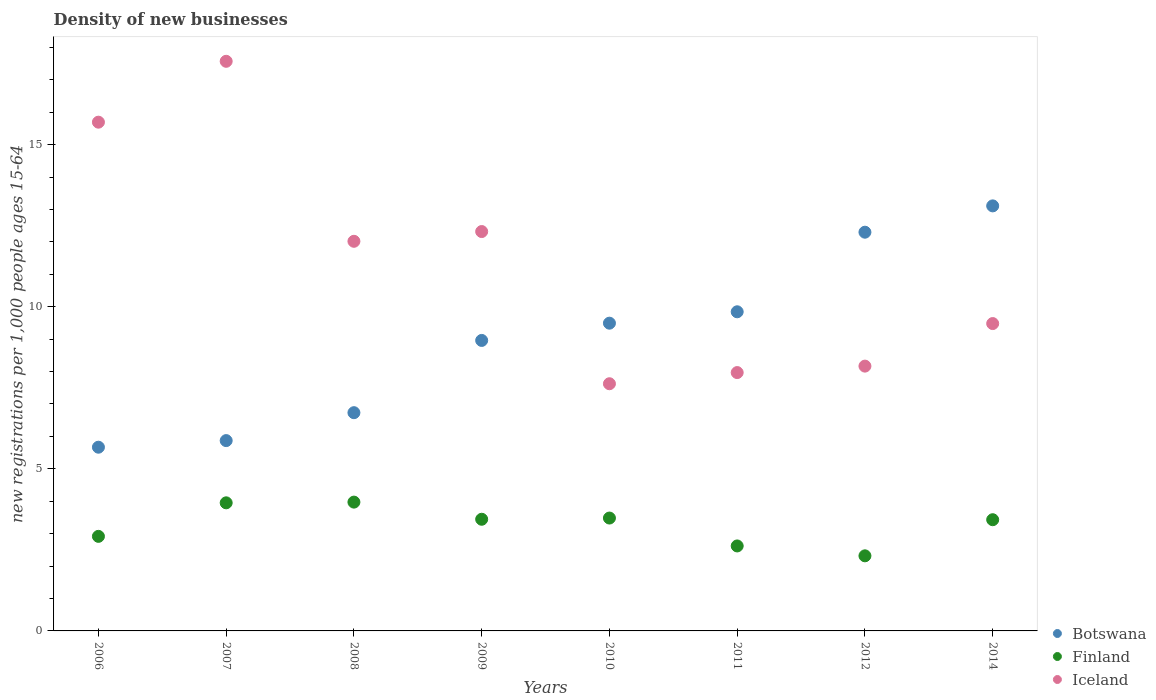How many different coloured dotlines are there?
Offer a terse response. 3. Is the number of dotlines equal to the number of legend labels?
Provide a short and direct response. Yes. What is the number of new registrations in Finland in 2006?
Your answer should be very brief. 2.92. Across all years, what is the maximum number of new registrations in Iceland?
Give a very brief answer. 17.57. Across all years, what is the minimum number of new registrations in Iceland?
Your answer should be compact. 7.62. In which year was the number of new registrations in Iceland minimum?
Your answer should be very brief. 2010. What is the total number of new registrations in Finland in the graph?
Your response must be concise. 26.13. What is the difference between the number of new registrations in Iceland in 2009 and that in 2014?
Your answer should be compact. 2.84. What is the difference between the number of new registrations in Iceland in 2006 and the number of new registrations in Botswana in 2011?
Ensure brevity in your answer.  5.85. What is the average number of new registrations in Botswana per year?
Your response must be concise. 9. In the year 2014, what is the difference between the number of new registrations in Iceland and number of new registrations in Botswana?
Offer a terse response. -3.63. In how many years, is the number of new registrations in Finland greater than 12?
Provide a succinct answer. 0. What is the ratio of the number of new registrations in Finland in 2007 to that in 2012?
Offer a very short reply. 1.71. Is the number of new registrations in Botswana in 2006 less than that in 2012?
Your answer should be very brief. Yes. Is the difference between the number of new registrations in Iceland in 2006 and 2008 greater than the difference between the number of new registrations in Botswana in 2006 and 2008?
Keep it short and to the point. Yes. What is the difference between the highest and the second highest number of new registrations in Botswana?
Give a very brief answer. 0.81. What is the difference between the highest and the lowest number of new registrations in Finland?
Ensure brevity in your answer.  1.66. Is the sum of the number of new registrations in Botswana in 2010 and 2012 greater than the maximum number of new registrations in Finland across all years?
Ensure brevity in your answer.  Yes. Is it the case that in every year, the sum of the number of new registrations in Finland and number of new registrations in Botswana  is greater than the number of new registrations in Iceland?
Offer a very short reply. No. Does the number of new registrations in Iceland monotonically increase over the years?
Keep it short and to the point. No. Is the number of new registrations in Iceland strictly greater than the number of new registrations in Botswana over the years?
Provide a short and direct response. No. Is the number of new registrations in Botswana strictly less than the number of new registrations in Iceland over the years?
Provide a short and direct response. No. How many years are there in the graph?
Offer a terse response. 8. What is the difference between two consecutive major ticks on the Y-axis?
Provide a succinct answer. 5. Does the graph contain any zero values?
Your answer should be very brief. No. How are the legend labels stacked?
Provide a succinct answer. Vertical. What is the title of the graph?
Provide a succinct answer. Density of new businesses. What is the label or title of the Y-axis?
Your answer should be very brief. New registrations per 1,0 people ages 15-64. What is the new registrations per 1,000 people ages 15-64 of Botswana in 2006?
Make the answer very short. 5.67. What is the new registrations per 1,000 people ages 15-64 of Finland in 2006?
Your answer should be compact. 2.92. What is the new registrations per 1,000 people ages 15-64 in Iceland in 2006?
Offer a very short reply. 15.69. What is the new registrations per 1,000 people ages 15-64 of Botswana in 2007?
Give a very brief answer. 5.87. What is the new registrations per 1,000 people ages 15-64 in Finland in 2007?
Provide a short and direct response. 3.95. What is the new registrations per 1,000 people ages 15-64 in Iceland in 2007?
Provide a succinct answer. 17.57. What is the new registrations per 1,000 people ages 15-64 in Botswana in 2008?
Offer a very short reply. 6.73. What is the new registrations per 1,000 people ages 15-64 of Finland in 2008?
Offer a terse response. 3.97. What is the new registrations per 1,000 people ages 15-64 of Iceland in 2008?
Give a very brief answer. 12.02. What is the new registrations per 1,000 people ages 15-64 of Botswana in 2009?
Offer a terse response. 8.96. What is the new registrations per 1,000 people ages 15-64 in Finland in 2009?
Ensure brevity in your answer.  3.44. What is the new registrations per 1,000 people ages 15-64 of Iceland in 2009?
Keep it short and to the point. 12.32. What is the new registrations per 1,000 people ages 15-64 in Botswana in 2010?
Offer a very short reply. 9.49. What is the new registrations per 1,000 people ages 15-64 of Finland in 2010?
Your answer should be compact. 3.48. What is the new registrations per 1,000 people ages 15-64 in Iceland in 2010?
Keep it short and to the point. 7.62. What is the new registrations per 1,000 people ages 15-64 in Botswana in 2011?
Your answer should be compact. 9.84. What is the new registrations per 1,000 people ages 15-64 in Finland in 2011?
Make the answer very short. 2.62. What is the new registrations per 1,000 people ages 15-64 in Iceland in 2011?
Offer a very short reply. 7.97. What is the new registrations per 1,000 people ages 15-64 of Botswana in 2012?
Ensure brevity in your answer.  12.3. What is the new registrations per 1,000 people ages 15-64 in Finland in 2012?
Give a very brief answer. 2.32. What is the new registrations per 1,000 people ages 15-64 in Iceland in 2012?
Offer a terse response. 8.17. What is the new registrations per 1,000 people ages 15-64 in Botswana in 2014?
Your response must be concise. 13.11. What is the new registrations per 1,000 people ages 15-64 of Finland in 2014?
Give a very brief answer. 3.43. What is the new registrations per 1,000 people ages 15-64 in Iceland in 2014?
Your response must be concise. 9.48. Across all years, what is the maximum new registrations per 1,000 people ages 15-64 of Botswana?
Keep it short and to the point. 13.11. Across all years, what is the maximum new registrations per 1,000 people ages 15-64 of Finland?
Your answer should be very brief. 3.97. Across all years, what is the maximum new registrations per 1,000 people ages 15-64 of Iceland?
Your response must be concise. 17.57. Across all years, what is the minimum new registrations per 1,000 people ages 15-64 of Botswana?
Keep it short and to the point. 5.67. Across all years, what is the minimum new registrations per 1,000 people ages 15-64 in Finland?
Give a very brief answer. 2.32. Across all years, what is the minimum new registrations per 1,000 people ages 15-64 in Iceland?
Your response must be concise. 7.62. What is the total new registrations per 1,000 people ages 15-64 of Botswana in the graph?
Offer a terse response. 71.97. What is the total new registrations per 1,000 people ages 15-64 in Finland in the graph?
Make the answer very short. 26.13. What is the total new registrations per 1,000 people ages 15-64 of Iceland in the graph?
Keep it short and to the point. 90.84. What is the difference between the new registrations per 1,000 people ages 15-64 in Botswana in 2006 and that in 2007?
Offer a terse response. -0.2. What is the difference between the new registrations per 1,000 people ages 15-64 in Finland in 2006 and that in 2007?
Offer a very short reply. -1.03. What is the difference between the new registrations per 1,000 people ages 15-64 of Iceland in 2006 and that in 2007?
Keep it short and to the point. -1.88. What is the difference between the new registrations per 1,000 people ages 15-64 in Botswana in 2006 and that in 2008?
Your answer should be very brief. -1.06. What is the difference between the new registrations per 1,000 people ages 15-64 in Finland in 2006 and that in 2008?
Make the answer very short. -1.06. What is the difference between the new registrations per 1,000 people ages 15-64 in Iceland in 2006 and that in 2008?
Make the answer very short. 3.67. What is the difference between the new registrations per 1,000 people ages 15-64 in Botswana in 2006 and that in 2009?
Provide a succinct answer. -3.29. What is the difference between the new registrations per 1,000 people ages 15-64 of Finland in 2006 and that in 2009?
Keep it short and to the point. -0.53. What is the difference between the new registrations per 1,000 people ages 15-64 in Iceland in 2006 and that in 2009?
Your answer should be very brief. 3.37. What is the difference between the new registrations per 1,000 people ages 15-64 in Botswana in 2006 and that in 2010?
Offer a very short reply. -3.83. What is the difference between the new registrations per 1,000 people ages 15-64 in Finland in 2006 and that in 2010?
Provide a succinct answer. -0.56. What is the difference between the new registrations per 1,000 people ages 15-64 in Iceland in 2006 and that in 2010?
Your answer should be compact. 8.07. What is the difference between the new registrations per 1,000 people ages 15-64 of Botswana in 2006 and that in 2011?
Provide a succinct answer. -4.18. What is the difference between the new registrations per 1,000 people ages 15-64 of Finland in 2006 and that in 2011?
Your response must be concise. 0.3. What is the difference between the new registrations per 1,000 people ages 15-64 in Iceland in 2006 and that in 2011?
Ensure brevity in your answer.  7.72. What is the difference between the new registrations per 1,000 people ages 15-64 in Botswana in 2006 and that in 2012?
Offer a very short reply. -6.63. What is the difference between the new registrations per 1,000 people ages 15-64 in Finland in 2006 and that in 2012?
Give a very brief answer. 0.6. What is the difference between the new registrations per 1,000 people ages 15-64 of Iceland in 2006 and that in 2012?
Offer a very short reply. 7.52. What is the difference between the new registrations per 1,000 people ages 15-64 in Botswana in 2006 and that in 2014?
Offer a terse response. -7.44. What is the difference between the new registrations per 1,000 people ages 15-64 in Finland in 2006 and that in 2014?
Your answer should be very brief. -0.51. What is the difference between the new registrations per 1,000 people ages 15-64 in Iceland in 2006 and that in 2014?
Your answer should be very brief. 6.21. What is the difference between the new registrations per 1,000 people ages 15-64 in Botswana in 2007 and that in 2008?
Ensure brevity in your answer.  -0.86. What is the difference between the new registrations per 1,000 people ages 15-64 in Finland in 2007 and that in 2008?
Make the answer very short. -0.02. What is the difference between the new registrations per 1,000 people ages 15-64 of Iceland in 2007 and that in 2008?
Offer a terse response. 5.55. What is the difference between the new registrations per 1,000 people ages 15-64 in Botswana in 2007 and that in 2009?
Offer a very short reply. -3.09. What is the difference between the new registrations per 1,000 people ages 15-64 of Finland in 2007 and that in 2009?
Provide a short and direct response. 0.51. What is the difference between the new registrations per 1,000 people ages 15-64 of Iceland in 2007 and that in 2009?
Offer a terse response. 5.25. What is the difference between the new registrations per 1,000 people ages 15-64 of Botswana in 2007 and that in 2010?
Give a very brief answer. -3.62. What is the difference between the new registrations per 1,000 people ages 15-64 of Finland in 2007 and that in 2010?
Offer a very short reply. 0.47. What is the difference between the new registrations per 1,000 people ages 15-64 in Iceland in 2007 and that in 2010?
Give a very brief answer. 9.95. What is the difference between the new registrations per 1,000 people ages 15-64 in Botswana in 2007 and that in 2011?
Your answer should be very brief. -3.97. What is the difference between the new registrations per 1,000 people ages 15-64 of Finland in 2007 and that in 2011?
Offer a terse response. 1.33. What is the difference between the new registrations per 1,000 people ages 15-64 of Iceland in 2007 and that in 2011?
Your response must be concise. 9.6. What is the difference between the new registrations per 1,000 people ages 15-64 of Botswana in 2007 and that in 2012?
Give a very brief answer. -6.43. What is the difference between the new registrations per 1,000 people ages 15-64 in Finland in 2007 and that in 2012?
Make the answer very short. 1.63. What is the difference between the new registrations per 1,000 people ages 15-64 of Iceland in 2007 and that in 2012?
Your response must be concise. 9.4. What is the difference between the new registrations per 1,000 people ages 15-64 in Botswana in 2007 and that in 2014?
Offer a very short reply. -7.24. What is the difference between the new registrations per 1,000 people ages 15-64 of Finland in 2007 and that in 2014?
Keep it short and to the point. 0.52. What is the difference between the new registrations per 1,000 people ages 15-64 of Iceland in 2007 and that in 2014?
Offer a very short reply. 8.09. What is the difference between the new registrations per 1,000 people ages 15-64 of Botswana in 2008 and that in 2009?
Ensure brevity in your answer.  -2.23. What is the difference between the new registrations per 1,000 people ages 15-64 of Finland in 2008 and that in 2009?
Keep it short and to the point. 0.53. What is the difference between the new registrations per 1,000 people ages 15-64 in Iceland in 2008 and that in 2009?
Make the answer very short. -0.3. What is the difference between the new registrations per 1,000 people ages 15-64 of Botswana in 2008 and that in 2010?
Make the answer very short. -2.76. What is the difference between the new registrations per 1,000 people ages 15-64 of Finland in 2008 and that in 2010?
Give a very brief answer. 0.49. What is the difference between the new registrations per 1,000 people ages 15-64 in Iceland in 2008 and that in 2010?
Offer a very short reply. 4.39. What is the difference between the new registrations per 1,000 people ages 15-64 of Botswana in 2008 and that in 2011?
Provide a succinct answer. -3.11. What is the difference between the new registrations per 1,000 people ages 15-64 of Finland in 2008 and that in 2011?
Provide a short and direct response. 1.35. What is the difference between the new registrations per 1,000 people ages 15-64 of Iceland in 2008 and that in 2011?
Your answer should be compact. 4.05. What is the difference between the new registrations per 1,000 people ages 15-64 of Botswana in 2008 and that in 2012?
Ensure brevity in your answer.  -5.57. What is the difference between the new registrations per 1,000 people ages 15-64 in Finland in 2008 and that in 2012?
Your response must be concise. 1.66. What is the difference between the new registrations per 1,000 people ages 15-64 of Iceland in 2008 and that in 2012?
Provide a short and direct response. 3.85. What is the difference between the new registrations per 1,000 people ages 15-64 in Botswana in 2008 and that in 2014?
Ensure brevity in your answer.  -6.38. What is the difference between the new registrations per 1,000 people ages 15-64 in Finland in 2008 and that in 2014?
Ensure brevity in your answer.  0.54. What is the difference between the new registrations per 1,000 people ages 15-64 of Iceland in 2008 and that in 2014?
Make the answer very short. 2.54. What is the difference between the new registrations per 1,000 people ages 15-64 of Botswana in 2009 and that in 2010?
Your answer should be very brief. -0.53. What is the difference between the new registrations per 1,000 people ages 15-64 of Finland in 2009 and that in 2010?
Ensure brevity in your answer.  -0.04. What is the difference between the new registrations per 1,000 people ages 15-64 of Iceland in 2009 and that in 2010?
Your response must be concise. 4.69. What is the difference between the new registrations per 1,000 people ages 15-64 of Botswana in 2009 and that in 2011?
Provide a succinct answer. -0.88. What is the difference between the new registrations per 1,000 people ages 15-64 of Finland in 2009 and that in 2011?
Ensure brevity in your answer.  0.82. What is the difference between the new registrations per 1,000 people ages 15-64 of Iceland in 2009 and that in 2011?
Your response must be concise. 4.35. What is the difference between the new registrations per 1,000 people ages 15-64 in Botswana in 2009 and that in 2012?
Your answer should be very brief. -3.34. What is the difference between the new registrations per 1,000 people ages 15-64 of Finland in 2009 and that in 2012?
Give a very brief answer. 1.13. What is the difference between the new registrations per 1,000 people ages 15-64 in Iceland in 2009 and that in 2012?
Give a very brief answer. 4.15. What is the difference between the new registrations per 1,000 people ages 15-64 of Botswana in 2009 and that in 2014?
Make the answer very short. -4.15. What is the difference between the new registrations per 1,000 people ages 15-64 of Finland in 2009 and that in 2014?
Offer a very short reply. 0.01. What is the difference between the new registrations per 1,000 people ages 15-64 in Iceland in 2009 and that in 2014?
Provide a short and direct response. 2.84. What is the difference between the new registrations per 1,000 people ages 15-64 of Botswana in 2010 and that in 2011?
Offer a terse response. -0.35. What is the difference between the new registrations per 1,000 people ages 15-64 of Finland in 2010 and that in 2011?
Provide a succinct answer. 0.86. What is the difference between the new registrations per 1,000 people ages 15-64 of Iceland in 2010 and that in 2011?
Ensure brevity in your answer.  -0.34. What is the difference between the new registrations per 1,000 people ages 15-64 of Botswana in 2010 and that in 2012?
Give a very brief answer. -2.81. What is the difference between the new registrations per 1,000 people ages 15-64 in Finland in 2010 and that in 2012?
Make the answer very short. 1.17. What is the difference between the new registrations per 1,000 people ages 15-64 of Iceland in 2010 and that in 2012?
Your answer should be compact. -0.54. What is the difference between the new registrations per 1,000 people ages 15-64 of Botswana in 2010 and that in 2014?
Ensure brevity in your answer.  -3.62. What is the difference between the new registrations per 1,000 people ages 15-64 in Finland in 2010 and that in 2014?
Make the answer very short. 0.05. What is the difference between the new registrations per 1,000 people ages 15-64 of Iceland in 2010 and that in 2014?
Provide a short and direct response. -1.86. What is the difference between the new registrations per 1,000 people ages 15-64 of Botswana in 2011 and that in 2012?
Provide a succinct answer. -2.45. What is the difference between the new registrations per 1,000 people ages 15-64 of Finland in 2011 and that in 2012?
Give a very brief answer. 0.3. What is the difference between the new registrations per 1,000 people ages 15-64 in Iceland in 2011 and that in 2012?
Give a very brief answer. -0.2. What is the difference between the new registrations per 1,000 people ages 15-64 in Botswana in 2011 and that in 2014?
Provide a succinct answer. -3.27. What is the difference between the new registrations per 1,000 people ages 15-64 in Finland in 2011 and that in 2014?
Keep it short and to the point. -0.81. What is the difference between the new registrations per 1,000 people ages 15-64 in Iceland in 2011 and that in 2014?
Ensure brevity in your answer.  -1.51. What is the difference between the new registrations per 1,000 people ages 15-64 in Botswana in 2012 and that in 2014?
Your answer should be compact. -0.81. What is the difference between the new registrations per 1,000 people ages 15-64 of Finland in 2012 and that in 2014?
Ensure brevity in your answer.  -1.11. What is the difference between the new registrations per 1,000 people ages 15-64 in Iceland in 2012 and that in 2014?
Provide a short and direct response. -1.31. What is the difference between the new registrations per 1,000 people ages 15-64 in Botswana in 2006 and the new registrations per 1,000 people ages 15-64 in Finland in 2007?
Your response must be concise. 1.72. What is the difference between the new registrations per 1,000 people ages 15-64 of Botswana in 2006 and the new registrations per 1,000 people ages 15-64 of Iceland in 2007?
Your answer should be very brief. -11.9. What is the difference between the new registrations per 1,000 people ages 15-64 of Finland in 2006 and the new registrations per 1,000 people ages 15-64 of Iceland in 2007?
Keep it short and to the point. -14.65. What is the difference between the new registrations per 1,000 people ages 15-64 in Botswana in 2006 and the new registrations per 1,000 people ages 15-64 in Finland in 2008?
Make the answer very short. 1.69. What is the difference between the new registrations per 1,000 people ages 15-64 in Botswana in 2006 and the new registrations per 1,000 people ages 15-64 in Iceland in 2008?
Offer a terse response. -6.35. What is the difference between the new registrations per 1,000 people ages 15-64 in Finland in 2006 and the new registrations per 1,000 people ages 15-64 in Iceland in 2008?
Give a very brief answer. -9.1. What is the difference between the new registrations per 1,000 people ages 15-64 of Botswana in 2006 and the new registrations per 1,000 people ages 15-64 of Finland in 2009?
Your answer should be very brief. 2.22. What is the difference between the new registrations per 1,000 people ages 15-64 of Botswana in 2006 and the new registrations per 1,000 people ages 15-64 of Iceland in 2009?
Offer a very short reply. -6.65. What is the difference between the new registrations per 1,000 people ages 15-64 in Finland in 2006 and the new registrations per 1,000 people ages 15-64 in Iceland in 2009?
Ensure brevity in your answer.  -9.4. What is the difference between the new registrations per 1,000 people ages 15-64 of Botswana in 2006 and the new registrations per 1,000 people ages 15-64 of Finland in 2010?
Your answer should be very brief. 2.19. What is the difference between the new registrations per 1,000 people ages 15-64 of Botswana in 2006 and the new registrations per 1,000 people ages 15-64 of Iceland in 2010?
Make the answer very short. -1.96. What is the difference between the new registrations per 1,000 people ages 15-64 in Finland in 2006 and the new registrations per 1,000 people ages 15-64 in Iceland in 2010?
Your answer should be very brief. -4.71. What is the difference between the new registrations per 1,000 people ages 15-64 in Botswana in 2006 and the new registrations per 1,000 people ages 15-64 in Finland in 2011?
Ensure brevity in your answer.  3.05. What is the difference between the new registrations per 1,000 people ages 15-64 in Botswana in 2006 and the new registrations per 1,000 people ages 15-64 in Iceland in 2011?
Your answer should be very brief. -2.3. What is the difference between the new registrations per 1,000 people ages 15-64 in Finland in 2006 and the new registrations per 1,000 people ages 15-64 in Iceland in 2011?
Keep it short and to the point. -5.05. What is the difference between the new registrations per 1,000 people ages 15-64 in Botswana in 2006 and the new registrations per 1,000 people ages 15-64 in Finland in 2012?
Ensure brevity in your answer.  3.35. What is the difference between the new registrations per 1,000 people ages 15-64 of Botswana in 2006 and the new registrations per 1,000 people ages 15-64 of Iceland in 2012?
Offer a very short reply. -2.5. What is the difference between the new registrations per 1,000 people ages 15-64 of Finland in 2006 and the new registrations per 1,000 people ages 15-64 of Iceland in 2012?
Your answer should be very brief. -5.25. What is the difference between the new registrations per 1,000 people ages 15-64 of Botswana in 2006 and the new registrations per 1,000 people ages 15-64 of Finland in 2014?
Provide a succinct answer. 2.24. What is the difference between the new registrations per 1,000 people ages 15-64 of Botswana in 2006 and the new registrations per 1,000 people ages 15-64 of Iceland in 2014?
Your response must be concise. -3.81. What is the difference between the new registrations per 1,000 people ages 15-64 in Finland in 2006 and the new registrations per 1,000 people ages 15-64 in Iceland in 2014?
Provide a succinct answer. -6.56. What is the difference between the new registrations per 1,000 people ages 15-64 of Botswana in 2007 and the new registrations per 1,000 people ages 15-64 of Finland in 2008?
Your response must be concise. 1.9. What is the difference between the new registrations per 1,000 people ages 15-64 in Botswana in 2007 and the new registrations per 1,000 people ages 15-64 in Iceland in 2008?
Provide a short and direct response. -6.15. What is the difference between the new registrations per 1,000 people ages 15-64 in Finland in 2007 and the new registrations per 1,000 people ages 15-64 in Iceland in 2008?
Keep it short and to the point. -8.07. What is the difference between the new registrations per 1,000 people ages 15-64 of Botswana in 2007 and the new registrations per 1,000 people ages 15-64 of Finland in 2009?
Your response must be concise. 2.43. What is the difference between the new registrations per 1,000 people ages 15-64 of Botswana in 2007 and the new registrations per 1,000 people ages 15-64 of Iceland in 2009?
Give a very brief answer. -6.45. What is the difference between the new registrations per 1,000 people ages 15-64 of Finland in 2007 and the new registrations per 1,000 people ages 15-64 of Iceland in 2009?
Offer a very short reply. -8.37. What is the difference between the new registrations per 1,000 people ages 15-64 of Botswana in 2007 and the new registrations per 1,000 people ages 15-64 of Finland in 2010?
Your response must be concise. 2.39. What is the difference between the new registrations per 1,000 people ages 15-64 in Botswana in 2007 and the new registrations per 1,000 people ages 15-64 in Iceland in 2010?
Your answer should be compact. -1.75. What is the difference between the new registrations per 1,000 people ages 15-64 of Finland in 2007 and the new registrations per 1,000 people ages 15-64 of Iceland in 2010?
Offer a terse response. -3.67. What is the difference between the new registrations per 1,000 people ages 15-64 of Botswana in 2007 and the new registrations per 1,000 people ages 15-64 of Finland in 2011?
Your answer should be compact. 3.25. What is the difference between the new registrations per 1,000 people ages 15-64 in Botswana in 2007 and the new registrations per 1,000 people ages 15-64 in Iceland in 2011?
Give a very brief answer. -2.1. What is the difference between the new registrations per 1,000 people ages 15-64 of Finland in 2007 and the new registrations per 1,000 people ages 15-64 of Iceland in 2011?
Provide a short and direct response. -4.02. What is the difference between the new registrations per 1,000 people ages 15-64 in Botswana in 2007 and the new registrations per 1,000 people ages 15-64 in Finland in 2012?
Ensure brevity in your answer.  3.55. What is the difference between the new registrations per 1,000 people ages 15-64 of Botswana in 2007 and the new registrations per 1,000 people ages 15-64 of Iceland in 2012?
Your response must be concise. -2.3. What is the difference between the new registrations per 1,000 people ages 15-64 of Finland in 2007 and the new registrations per 1,000 people ages 15-64 of Iceland in 2012?
Offer a terse response. -4.22. What is the difference between the new registrations per 1,000 people ages 15-64 in Botswana in 2007 and the new registrations per 1,000 people ages 15-64 in Finland in 2014?
Keep it short and to the point. 2.44. What is the difference between the new registrations per 1,000 people ages 15-64 of Botswana in 2007 and the new registrations per 1,000 people ages 15-64 of Iceland in 2014?
Ensure brevity in your answer.  -3.61. What is the difference between the new registrations per 1,000 people ages 15-64 of Finland in 2007 and the new registrations per 1,000 people ages 15-64 of Iceland in 2014?
Offer a very short reply. -5.53. What is the difference between the new registrations per 1,000 people ages 15-64 of Botswana in 2008 and the new registrations per 1,000 people ages 15-64 of Finland in 2009?
Your response must be concise. 3.29. What is the difference between the new registrations per 1,000 people ages 15-64 of Botswana in 2008 and the new registrations per 1,000 people ages 15-64 of Iceland in 2009?
Keep it short and to the point. -5.59. What is the difference between the new registrations per 1,000 people ages 15-64 in Finland in 2008 and the new registrations per 1,000 people ages 15-64 in Iceland in 2009?
Your answer should be very brief. -8.35. What is the difference between the new registrations per 1,000 people ages 15-64 of Botswana in 2008 and the new registrations per 1,000 people ages 15-64 of Finland in 2010?
Ensure brevity in your answer.  3.25. What is the difference between the new registrations per 1,000 people ages 15-64 in Botswana in 2008 and the new registrations per 1,000 people ages 15-64 in Iceland in 2010?
Give a very brief answer. -0.89. What is the difference between the new registrations per 1,000 people ages 15-64 of Finland in 2008 and the new registrations per 1,000 people ages 15-64 of Iceland in 2010?
Offer a very short reply. -3.65. What is the difference between the new registrations per 1,000 people ages 15-64 in Botswana in 2008 and the new registrations per 1,000 people ages 15-64 in Finland in 2011?
Your response must be concise. 4.11. What is the difference between the new registrations per 1,000 people ages 15-64 of Botswana in 2008 and the new registrations per 1,000 people ages 15-64 of Iceland in 2011?
Ensure brevity in your answer.  -1.24. What is the difference between the new registrations per 1,000 people ages 15-64 of Finland in 2008 and the new registrations per 1,000 people ages 15-64 of Iceland in 2011?
Offer a terse response. -4. What is the difference between the new registrations per 1,000 people ages 15-64 in Botswana in 2008 and the new registrations per 1,000 people ages 15-64 in Finland in 2012?
Your answer should be compact. 4.42. What is the difference between the new registrations per 1,000 people ages 15-64 in Botswana in 2008 and the new registrations per 1,000 people ages 15-64 in Iceland in 2012?
Your answer should be compact. -1.44. What is the difference between the new registrations per 1,000 people ages 15-64 in Finland in 2008 and the new registrations per 1,000 people ages 15-64 in Iceland in 2012?
Offer a terse response. -4.19. What is the difference between the new registrations per 1,000 people ages 15-64 of Botswana in 2008 and the new registrations per 1,000 people ages 15-64 of Finland in 2014?
Offer a very short reply. 3.3. What is the difference between the new registrations per 1,000 people ages 15-64 of Botswana in 2008 and the new registrations per 1,000 people ages 15-64 of Iceland in 2014?
Give a very brief answer. -2.75. What is the difference between the new registrations per 1,000 people ages 15-64 in Finland in 2008 and the new registrations per 1,000 people ages 15-64 in Iceland in 2014?
Ensure brevity in your answer.  -5.51. What is the difference between the new registrations per 1,000 people ages 15-64 in Botswana in 2009 and the new registrations per 1,000 people ages 15-64 in Finland in 2010?
Ensure brevity in your answer.  5.48. What is the difference between the new registrations per 1,000 people ages 15-64 in Botswana in 2009 and the new registrations per 1,000 people ages 15-64 in Iceland in 2010?
Give a very brief answer. 1.34. What is the difference between the new registrations per 1,000 people ages 15-64 in Finland in 2009 and the new registrations per 1,000 people ages 15-64 in Iceland in 2010?
Give a very brief answer. -4.18. What is the difference between the new registrations per 1,000 people ages 15-64 in Botswana in 2009 and the new registrations per 1,000 people ages 15-64 in Finland in 2011?
Make the answer very short. 6.34. What is the difference between the new registrations per 1,000 people ages 15-64 in Finland in 2009 and the new registrations per 1,000 people ages 15-64 in Iceland in 2011?
Provide a short and direct response. -4.52. What is the difference between the new registrations per 1,000 people ages 15-64 of Botswana in 2009 and the new registrations per 1,000 people ages 15-64 of Finland in 2012?
Give a very brief answer. 6.64. What is the difference between the new registrations per 1,000 people ages 15-64 in Botswana in 2009 and the new registrations per 1,000 people ages 15-64 in Iceland in 2012?
Your response must be concise. 0.79. What is the difference between the new registrations per 1,000 people ages 15-64 in Finland in 2009 and the new registrations per 1,000 people ages 15-64 in Iceland in 2012?
Give a very brief answer. -4.72. What is the difference between the new registrations per 1,000 people ages 15-64 of Botswana in 2009 and the new registrations per 1,000 people ages 15-64 of Finland in 2014?
Your answer should be very brief. 5.53. What is the difference between the new registrations per 1,000 people ages 15-64 in Botswana in 2009 and the new registrations per 1,000 people ages 15-64 in Iceland in 2014?
Your response must be concise. -0.52. What is the difference between the new registrations per 1,000 people ages 15-64 in Finland in 2009 and the new registrations per 1,000 people ages 15-64 in Iceland in 2014?
Your answer should be very brief. -6.04. What is the difference between the new registrations per 1,000 people ages 15-64 of Botswana in 2010 and the new registrations per 1,000 people ages 15-64 of Finland in 2011?
Make the answer very short. 6.87. What is the difference between the new registrations per 1,000 people ages 15-64 of Botswana in 2010 and the new registrations per 1,000 people ages 15-64 of Iceland in 2011?
Offer a terse response. 1.52. What is the difference between the new registrations per 1,000 people ages 15-64 of Finland in 2010 and the new registrations per 1,000 people ages 15-64 of Iceland in 2011?
Give a very brief answer. -4.49. What is the difference between the new registrations per 1,000 people ages 15-64 in Botswana in 2010 and the new registrations per 1,000 people ages 15-64 in Finland in 2012?
Offer a very short reply. 7.18. What is the difference between the new registrations per 1,000 people ages 15-64 in Botswana in 2010 and the new registrations per 1,000 people ages 15-64 in Iceland in 2012?
Provide a succinct answer. 1.32. What is the difference between the new registrations per 1,000 people ages 15-64 in Finland in 2010 and the new registrations per 1,000 people ages 15-64 in Iceland in 2012?
Provide a succinct answer. -4.69. What is the difference between the new registrations per 1,000 people ages 15-64 in Botswana in 2010 and the new registrations per 1,000 people ages 15-64 in Finland in 2014?
Ensure brevity in your answer.  6.06. What is the difference between the new registrations per 1,000 people ages 15-64 of Botswana in 2010 and the new registrations per 1,000 people ages 15-64 of Iceland in 2014?
Offer a terse response. 0.01. What is the difference between the new registrations per 1,000 people ages 15-64 of Finland in 2010 and the new registrations per 1,000 people ages 15-64 of Iceland in 2014?
Give a very brief answer. -6. What is the difference between the new registrations per 1,000 people ages 15-64 of Botswana in 2011 and the new registrations per 1,000 people ages 15-64 of Finland in 2012?
Keep it short and to the point. 7.53. What is the difference between the new registrations per 1,000 people ages 15-64 of Botswana in 2011 and the new registrations per 1,000 people ages 15-64 of Iceland in 2012?
Your answer should be compact. 1.68. What is the difference between the new registrations per 1,000 people ages 15-64 of Finland in 2011 and the new registrations per 1,000 people ages 15-64 of Iceland in 2012?
Your response must be concise. -5.55. What is the difference between the new registrations per 1,000 people ages 15-64 in Botswana in 2011 and the new registrations per 1,000 people ages 15-64 in Finland in 2014?
Your answer should be compact. 6.41. What is the difference between the new registrations per 1,000 people ages 15-64 of Botswana in 2011 and the new registrations per 1,000 people ages 15-64 of Iceland in 2014?
Keep it short and to the point. 0.36. What is the difference between the new registrations per 1,000 people ages 15-64 of Finland in 2011 and the new registrations per 1,000 people ages 15-64 of Iceland in 2014?
Ensure brevity in your answer.  -6.86. What is the difference between the new registrations per 1,000 people ages 15-64 of Botswana in 2012 and the new registrations per 1,000 people ages 15-64 of Finland in 2014?
Give a very brief answer. 8.87. What is the difference between the new registrations per 1,000 people ages 15-64 of Botswana in 2012 and the new registrations per 1,000 people ages 15-64 of Iceland in 2014?
Your answer should be very brief. 2.82. What is the difference between the new registrations per 1,000 people ages 15-64 of Finland in 2012 and the new registrations per 1,000 people ages 15-64 of Iceland in 2014?
Your answer should be very brief. -7.16. What is the average new registrations per 1,000 people ages 15-64 in Botswana per year?
Give a very brief answer. 9. What is the average new registrations per 1,000 people ages 15-64 in Finland per year?
Make the answer very short. 3.27. What is the average new registrations per 1,000 people ages 15-64 of Iceland per year?
Offer a very short reply. 11.35. In the year 2006, what is the difference between the new registrations per 1,000 people ages 15-64 of Botswana and new registrations per 1,000 people ages 15-64 of Finland?
Provide a short and direct response. 2.75. In the year 2006, what is the difference between the new registrations per 1,000 people ages 15-64 of Botswana and new registrations per 1,000 people ages 15-64 of Iceland?
Offer a very short reply. -10.03. In the year 2006, what is the difference between the new registrations per 1,000 people ages 15-64 in Finland and new registrations per 1,000 people ages 15-64 in Iceland?
Provide a short and direct response. -12.78. In the year 2007, what is the difference between the new registrations per 1,000 people ages 15-64 in Botswana and new registrations per 1,000 people ages 15-64 in Finland?
Provide a succinct answer. 1.92. In the year 2007, what is the difference between the new registrations per 1,000 people ages 15-64 in Botswana and new registrations per 1,000 people ages 15-64 in Iceland?
Provide a succinct answer. -11.7. In the year 2007, what is the difference between the new registrations per 1,000 people ages 15-64 of Finland and new registrations per 1,000 people ages 15-64 of Iceland?
Give a very brief answer. -13.62. In the year 2008, what is the difference between the new registrations per 1,000 people ages 15-64 of Botswana and new registrations per 1,000 people ages 15-64 of Finland?
Your answer should be compact. 2.76. In the year 2008, what is the difference between the new registrations per 1,000 people ages 15-64 in Botswana and new registrations per 1,000 people ages 15-64 in Iceland?
Your answer should be very brief. -5.29. In the year 2008, what is the difference between the new registrations per 1,000 people ages 15-64 of Finland and new registrations per 1,000 people ages 15-64 of Iceland?
Ensure brevity in your answer.  -8.04. In the year 2009, what is the difference between the new registrations per 1,000 people ages 15-64 in Botswana and new registrations per 1,000 people ages 15-64 in Finland?
Offer a terse response. 5.52. In the year 2009, what is the difference between the new registrations per 1,000 people ages 15-64 of Botswana and new registrations per 1,000 people ages 15-64 of Iceland?
Provide a short and direct response. -3.36. In the year 2009, what is the difference between the new registrations per 1,000 people ages 15-64 of Finland and new registrations per 1,000 people ages 15-64 of Iceland?
Provide a short and direct response. -8.87. In the year 2010, what is the difference between the new registrations per 1,000 people ages 15-64 of Botswana and new registrations per 1,000 people ages 15-64 of Finland?
Make the answer very short. 6.01. In the year 2010, what is the difference between the new registrations per 1,000 people ages 15-64 of Botswana and new registrations per 1,000 people ages 15-64 of Iceland?
Ensure brevity in your answer.  1.87. In the year 2010, what is the difference between the new registrations per 1,000 people ages 15-64 of Finland and new registrations per 1,000 people ages 15-64 of Iceland?
Your answer should be compact. -4.14. In the year 2011, what is the difference between the new registrations per 1,000 people ages 15-64 of Botswana and new registrations per 1,000 people ages 15-64 of Finland?
Ensure brevity in your answer.  7.22. In the year 2011, what is the difference between the new registrations per 1,000 people ages 15-64 in Botswana and new registrations per 1,000 people ages 15-64 in Iceland?
Provide a short and direct response. 1.87. In the year 2011, what is the difference between the new registrations per 1,000 people ages 15-64 in Finland and new registrations per 1,000 people ages 15-64 in Iceland?
Your answer should be very brief. -5.35. In the year 2012, what is the difference between the new registrations per 1,000 people ages 15-64 in Botswana and new registrations per 1,000 people ages 15-64 in Finland?
Keep it short and to the point. 9.98. In the year 2012, what is the difference between the new registrations per 1,000 people ages 15-64 in Botswana and new registrations per 1,000 people ages 15-64 in Iceland?
Make the answer very short. 4.13. In the year 2012, what is the difference between the new registrations per 1,000 people ages 15-64 of Finland and new registrations per 1,000 people ages 15-64 of Iceland?
Your answer should be compact. -5.85. In the year 2014, what is the difference between the new registrations per 1,000 people ages 15-64 of Botswana and new registrations per 1,000 people ages 15-64 of Finland?
Offer a very short reply. 9.68. In the year 2014, what is the difference between the new registrations per 1,000 people ages 15-64 in Botswana and new registrations per 1,000 people ages 15-64 in Iceland?
Keep it short and to the point. 3.63. In the year 2014, what is the difference between the new registrations per 1,000 people ages 15-64 in Finland and new registrations per 1,000 people ages 15-64 in Iceland?
Offer a very short reply. -6.05. What is the ratio of the new registrations per 1,000 people ages 15-64 in Botswana in 2006 to that in 2007?
Offer a very short reply. 0.97. What is the ratio of the new registrations per 1,000 people ages 15-64 in Finland in 2006 to that in 2007?
Keep it short and to the point. 0.74. What is the ratio of the new registrations per 1,000 people ages 15-64 in Iceland in 2006 to that in 2007?
Ensure brevity in your answer.  0.89. What is the ratio of the new registrations per 1,000 people ages 15-64 in Botswana in 2006 to that in 2008?
Make the answer very short. 0.84. What is the ratio of the new registrations per 1,000 people ages 15-64 of Finland in 2006 to that in 2008?
Give a very brief answer. 0.73. What is the ratio of the new registrations per 1,000 people ages 15-64 of Iceland in 2006 to that in 2008?
Provide a short and direct response. 1.31. What is the ratio of the new registrations per 1,000 people ages 15-64 of Botswana in 2006 to that in 2009?
Your answer should be very brief. 0.63. What is the ratio of the new registrations per 1,000 people ages 15-64 in Finland in 2006 to that in 2009?
Make the answer very short. 0.85. What is the ratio of the new registrations per 1,000 people ages 15-64 of Iceland in 2006 to that in 2009?
Offer a terse response. 1.27. What is the ratio of the new registrations per 1,000 people ages 15-64 in Botswana in 2006 to that in 2010?
Ensure brevity in your answer.  0.6. What is the ratio of the new registrations per 1,000 people ages 15-64 of Finland in 2006 to that in 2010?
Offer a terse response. 0.84. What is the ratio of the new registrations per 1,000 people ages 15-64 in Iceland in 2006 to that in 2010?
Offer a terse response. 2.06. What is the ratio of the new registrations per 1,000 people ages 15-64 in Botswana in 2006 to that in 2011?
Provide a short and direct response. 0.58. What is the ratio of the new registrations per 1,000 people ages 15-64 in Finland in 2006 to that in 2011?
Your response must be concise. 1.11. What is the ratio of the new registrations per 1,000 people ages 15-64 of Iceland in 2006 to that in 2011?
Give a very brief answer. 1.97. What is the ratio of the new registrations per 1,000 people ages 15-64 of Botswana in 2006 to that in 2012?
Give a very brief answer. 0.46. What is the ratio of the new registrations per 1,000 people ages 15-64 in Finland in 2006 to that in 2012?
Provide a short and direct response. 1.26. What is the ratio of the new registrations per 1,000 people ages 15-64 of Iceland in 2006 to that in 2012?
Keep it short and to the point. 1.92. What is the ratio of the new registrations per 1,000 people ages 15-64 of Botswana in 2006 to that in 2014?
Provide a short and direct response. 0.43. What is the ratio of the new registrations per 1,000 people ages 15-64 in Finland in 2006 to that in 2014?
Give a very brief answer. 0.85. What is the ratio of the new registrations per 1,000 people ages 15-64 in Iceland in 2006 to that in 2014?
Offer a terse response. 1.66. What is the ratio of the new registrations per 1,000 people ages 15-64 of Botswana in 2007 to that in 2008?
Provide a succinct answer. 0.87. What is the ratio of the new registrations per 1,000 people ages 15-64 of Iceland in 2007 to that in 2008?
Your answer should be compact. 1.46. What is the ratio of the new registrations per 1,000 people ages 15-64 of Botswana in 2007 to that in 2009?
Make the answer very short. 0.66. What is the ratio of the new registrations per 1,000 people ages 15-64 in Finland in 2007 to that in 2009?
Keep it short and to the point. 1.15. What is the ratio of the new registrations per 1,000 people ages 15-64 in Iceland in 2007 to that in 2009?
Provide a succinct answer. 1.43. What is the ratio of the new registrations per 1,000 people ages 15-64 in Botswana in 2007 to that in 2010?
Your answer should be very brief. 0.62. What is the ratio of the new registrations per 1,000 people ages 15-64 of Finland in 2007 to that in 2010?
Provide a short and direct response. 1.13. What is the ratio of the new registrations per 1,000 people ages 15-64 of Iceland in 2007 to that in 2010?
Your answer should be compact. 2.3. What is the ratio of the new registrations per 1,000 people ages 15-64 in Botswana in 2007 to that in 2011?
Your answer should be very brief. 0.6. What is the ratio of the new registrations per 1,000 people ages 15-64 of Finland in 2007 to that in 2011?
Keep it short and to the point. 1.51. What is the ratio of the new registrations per 1,000 people ages 15-64 of Iceland in 2007 to that in 2011?
Give a very brief answer. 2.2. What is the ratio of the new registrations per 1,000 people ages 15-64 of Botswana in 2007 to that in 2012?
Give a very brief answer. 0.48. What is the ratio of the new registrations per 1,000 people ages 15-64 of Finland in 2007 to that in 2012?
Make the answer very short. 1.71. What is the ratio of the new registrations per 1,000 people ages 15-64 in Iceland in 2007 to that in 2012?
Your answer should be very brief. 2.15. What is the ratio of the new registrations per 1,000 people ages 15-64 of Botswana in 2007 to that in 2014?
Provide a short and direct response. 0.45. What is the ratio of the new registrations per 1,000 people ages 15-64 in Finland in 2007 to that in 2014?
Provide a succinct answer. 1.15. What is the ratio of the new registrations per 1,000 people ages 15-64 of Iceland in 2007 to that in 2014?
Make the answer very short. 1.85. What is the ratio of the new registrations per 1,000 people ages 15-64 of Botswana in 2008 to that in 2009?
Provide a succinct answer. 0.75. What is the ratio of the new registrations per 1,000 people ages 15-64 in Finland in 2008 to that in 2009?
Offer a terse response. 1.15. What is the ratio of the new registrations per 1,000 people ages 15-64 of Iceland in 2008 to that in 2009?
Offer a very short reply. 0.98. What is the ratio of the new registrations per 1,000 people ages 15-64 of Botswana in 2008 to that in 2010?
Provide a short and direct response. 0.71. What is the ratio of the new registrations per 1,000 people ages 15-64 of Finland in 2008 to that in 2010?
Offer a terse response. 1.14. What is the ratio of the new registrations per 1,000 people ages 15-64 of Iceland in 2008 to that in 2010?
Give a very brief answer. 1.58. What is the ratio of the new registrations per 1,000 people ages 15-64 of Botswana in 2008 to that in 2011?
Provide a short and direct response. 0.68. What is the ratio of the new registrations per 1,000 people ages 15-64 in Finland in 2008 to that in 2011?
Provide a succinct answer. 1.52. What is the ratio of the new registrations per 1,000 people ages 15-64 in Iceland in 2008 to that in 2011?
Your response must be concise. 1.51. What is the ratio of the new registrations per 1,000 people ages 15-64 in Botswana in 2008 to that in 2012?
Ensure brevity in your answer.  0.55. What is the ratio of the new registrations per 1,000 people ages 15-64 in Finland in 2008 to that in 2012?
Your answer should be compact. 1.72. What is the ratio of the new registrations per 1,000 people ages 15-64 in Iceland in 2008 to that in 2012?
Keep it short and to the point. 1.47. What is the ratio of the new registrations per 1,000 people ages 15-64 of Botswana in 2008 to that in 2014?
Make the answer very short. 0.51. What is the ratio of the new registrations per 1,000 people ages 15-64 of Finland in 2008 to that in 2014?
Your response must be concise. 1.16. What is the ratio of the new registrations per 1,000 people ages 15-64 in Iceland in 2008 to that in 2014?
Offer a terse response. 1.27. What is the ratio of the new registrations per 1,000 people ages 15-64 of Botswana in 2009 to that in 2010?
Provide a succinct answer. 0.94. What is the ratio of the new registrations per 1,000 people ages 15-64 of Finland in 2009 to that in 2010?
Your answer should be compact. 0.99. What is the ratio of the new registrations per 1,000 people ages 15-64 in Iceland in 2009 to that in 2010?
Your answer should be very brief. 1.62. What is the ratio of the new registrations per 1,000 people ages 15-64 in Botswana in 2009 to that in 2011?
Make the answer very short. 0.91. What is the ratio of the new registrations per 1,000 people ages 15-64 in Finland in 2009 to that in 2011?
Keep it short and to the point. 1.31. What is the ratio of the new registrations per 1,000 people ages 15-64 in Iceland in 2009 to that in 2011?
Make the answer very short. 1.55. What is the ratio of the new registrations per 1,000 people ages 15-64 in Botswana in 2009 to that in 2012?
Make the answer very short. 0.73. What is the ratio of the new registrations per 1,000 people ages 15-64 in Finland in 2009 to that in 2012?
Keep it short and to the point. 1.49. What is the ratio of the new registrations per 1,000 people ages 15-64 in Iceland in 2009 to that in 2012?
Your response must be concise. 1.51. What is the ratio of the new registrations per 1,000 people ages 15-64 of Botswana in 2009 to that in 2014?
Provide a short and direct response. 0.68. What is the ratio of the new registrations per 1,000 people ages 15-64 in Iceland in 2009 to that in 2014?
Your response must be concise. 1.3. What is the ratio of the new registrations per 1,000 people ages 15-64 of Botswana in 2010 to that in 2011?
Offer a very short reply. 0.96. What is the ratio of the new registrations per 1,000 people ages 15-64 of Finland in 2010 to that in 2011?
Ensure brevity in your answer.  1.33. What is the ratio of the new registrations per 1,000 people ages 15-64 in Iceland in 2010 to that in 2011?
Your answer should be compact. 0.96. What is the ratio of the new registrations per 1,000 people ages 15-64 in Botswana in 2010 to that in 2012?
Give a very brief answer. 0.77. What is the ratio of the new registrations per 1,000 people ages 15-64 in Finland in 2010 to that in 2012?
Offer a very short reply. 1.5. What is the ratio of the new registrations per 1,000 people ages 15-64 of Iceland in 2010 to that in 2012?
Offer a terse response. 0.93. What is the ratio of the new registrations per 1,000 people ages 15-64 of Botswana in 2010 to that in 2014?
Your response must be concise. 0.72. What is the ratio of the new registrations per 1,000 people ages 15-64 of Finland in 2010 to that in 2014?
Your response must be concise. 1.01. What is the ratio of the new registrations per 1,000 people ages 15-64 of Iceland in 2010 to that in 2014?
Provide a succinct answer. 0.8. What is the ratio of the new registrations per 1,000 people ages 15-64 of Botswana in 2011 to that in 2012?
Your response must be concise. 0.8. What is the ratio of the new registrations per 1,000 people ages 15-64 in Finland in 2011 to that in 2012?
Make the answer very short. 1.13. What is the ratio of the new registrations per 1,000 people ages 15-64 of Iceland in 2011 to that in 2012?
Give a very brief answer. 0.98. What is the ratio of the new registrations per 1,000 people ages 15-64 in Botswana in 2011 to that in 2014?
Provide a short and direct response. 0.75. What is the ratio of the new registrations per 1,000 people ages 15-64 in Finland in 2011 to that in 2014?
Your answer should be compact. 0.76. What is the ratio of the new registrations per 1,000 people ages 15-64 of Iceland in 2011 to that in 2014?
Your response must be concise. 0.84. What is the ratio of the new registrations per 1,000 people ages 15-64 of Botswana in 2012 to that in 2014?
Your answer should be very brief. 0.94. What is the ratio of the new registrations per 1,000 people ages 15-64 in Finland in 2012 to that in 2014?
Give a very brief answer. 0.68. What is the ratio of the new registrations per 1,000 people ages 15-64 in Iceland in 2012 to that in 2014?
Provide a succinct answer. 0.86. What is the difference between the highest and the second highest new registrations per 1,000 people ages 15-64 of Botswana?
Ensure brevity in your answer.  0.81. What is the difference between the highest and the second highest new registrations per 1,000 people ages 15-64 in Finland?
Provide a short and direct response. 0.02. What is the difference between the highest and the second highest new registrations per 1,000 people ages 15-64 of Iceland?
Ensure brevity in your answer.  1.88. What is the difference between the highest and the lowest new registrations per 1,000 people ages 15-64 of Botswana?
Your response must be concise. 7.44. What is the difference between the highest and the lowest new registrations per 1,000 people ages 15-64 in Finland?
Offer a very short reply. 1.66. What is the difference between the highest and the lowest new registrations per 1,000 people ages 15-64 of Iceland?
Your response must be concise. 9.95. 